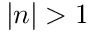Convert formula to latex. <formula><loc_0><loc_0><loc_500><loc_500>| n | > 1</formula> 